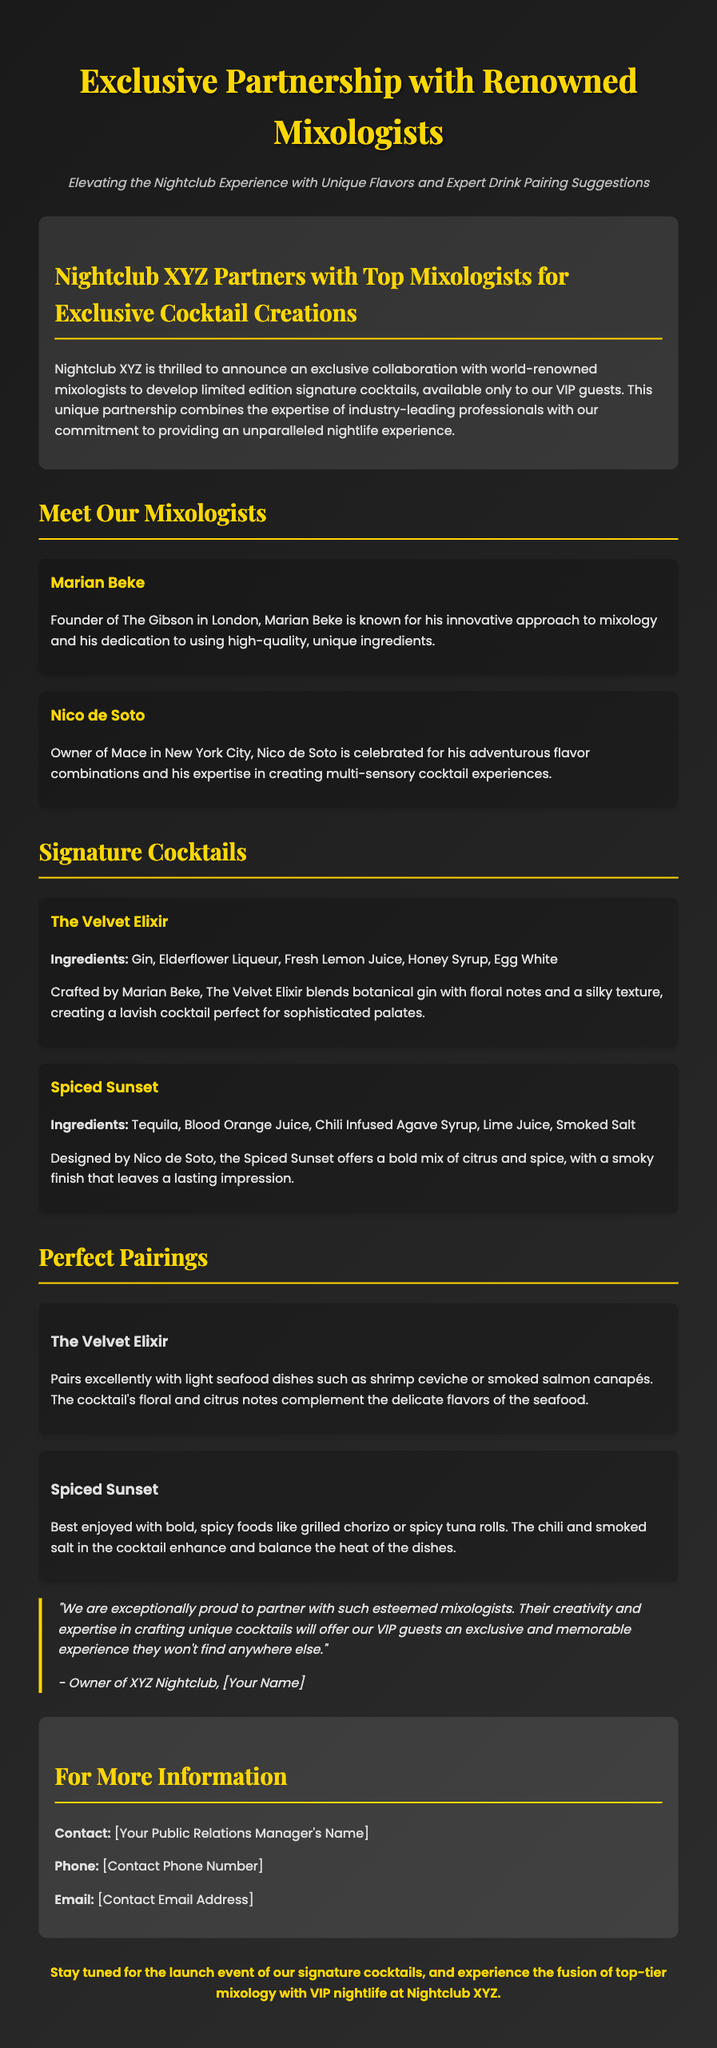What is the title of the press release? The title of the press release is prominently displayed at the top of the document.
Answer: Exclusive Partnership with Renowned Mixologists Who are the mixologists mentioned in the press release? The document lists the names of two mixologists involved in the partnership.
Answer: Marian Beke and Nico de Soto What is The Velvet Elixir crafted with? The ingredients of The Velvet Elixir are detailed in the section about signature cocktails.
Answer: Gin, Elderflower Liqueur, Fresh Lemon Juice, Honey Syrup, Egg White Which cocktail pairs well with light seafood dishes? The document specifies which cocktail is best paired with certain types of food.
Answer: The Velvet Elixir What is the unique aspect of the partnership described in the press release? The release highlights the innovative cocktail creations exclusive to VIP guests.
Answer: Limited edition signature cocktails What event is upcoming according to the conclusion? The conclusion refers to an event related to the launch of something new at the nightclub.
Answer: The launch event of our signature cocktails What type of document is this? The structure and content indicate the purpose of the document is to announce a new collaboration.
Answer: Press release 